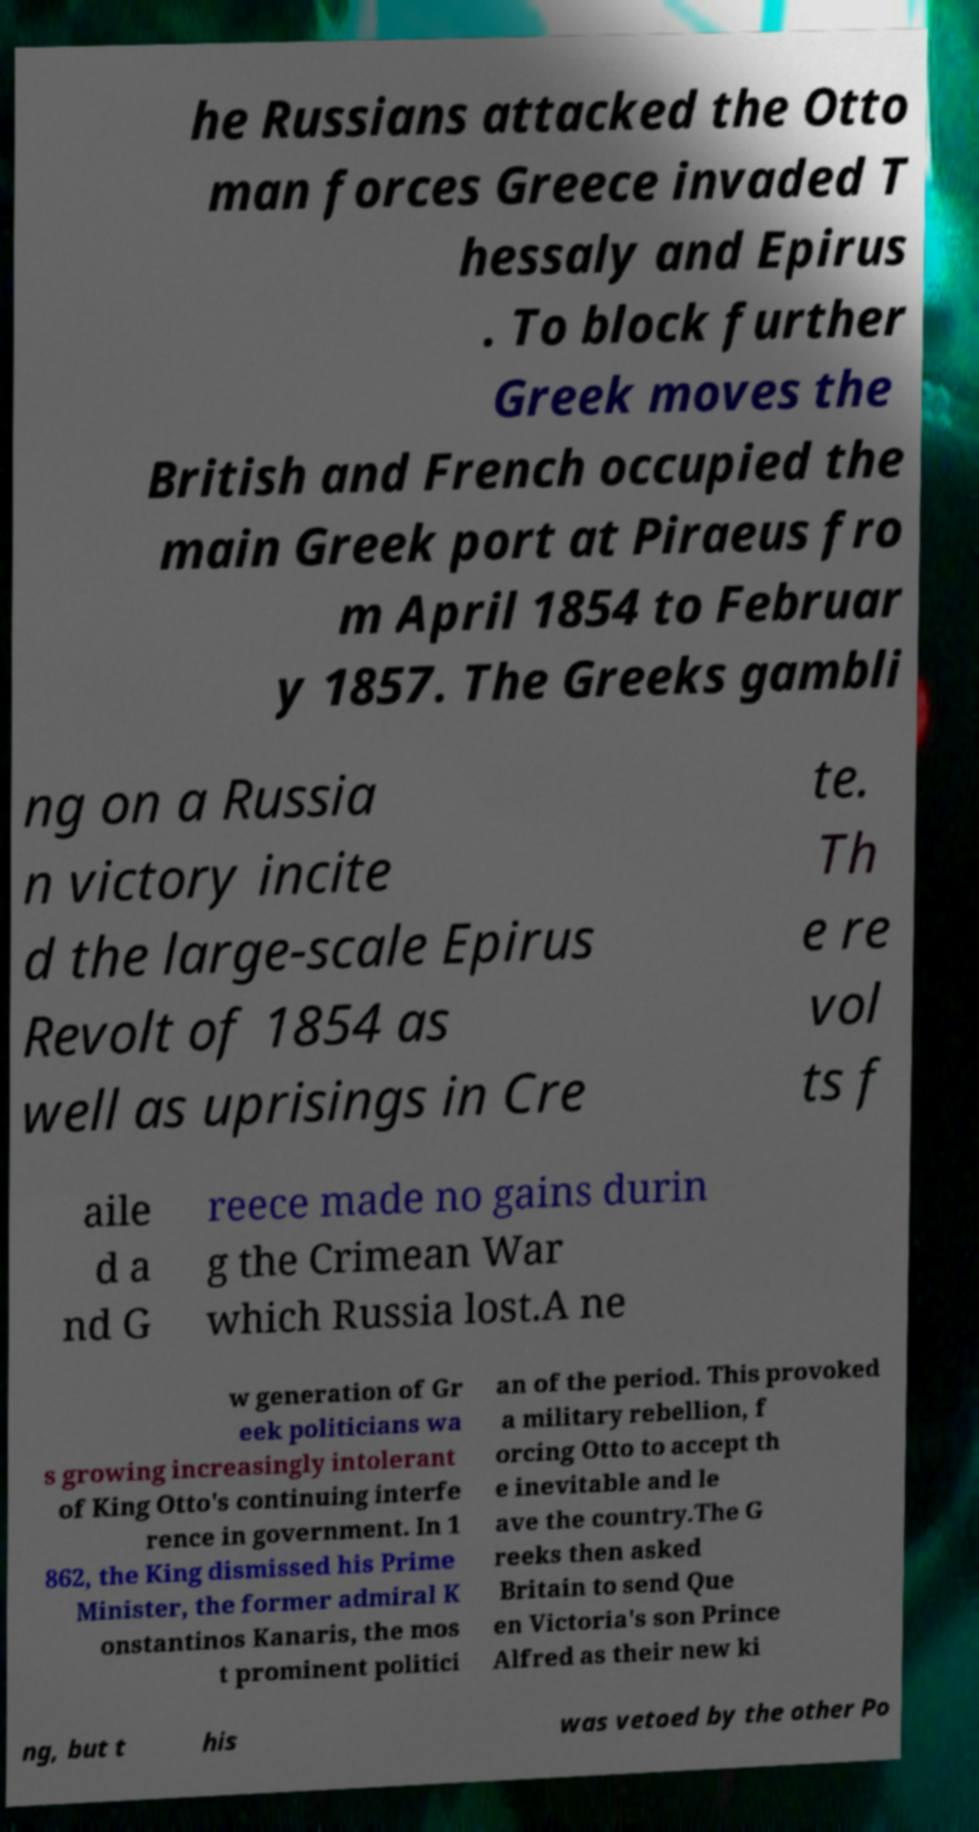Can you accurately transcribe the text from the provided image for me? he Russians attacked the Otto man forces Greece invaded T hessaly and Epirus . To block further Greek moves the British and French occupied the main Greek port at Piraeus fro m April 1854 to Februar y 1857. The Greeks gambli ng on a Russia n victory incite d the large-scale Epirus Revolt of 1854 as well as uprisings in Cre te. Th e re vol ts f aile d a nd G reece made no gains durin g the Crimean War which Russia lost.A ne w generation of Gr eek politicians wa s growing increasingly intolerant of King Otto's continuing interfe rence in government. In 1 862, the King dismissed his Prime Minister, the former admiral K onstantinos Kanaris, the mos t prominent politici an of the period. This provoked a military rebellion, f orcing Otto to accept th e inevitable and le ave the country.The G reeks then asked Britain to send Que en Victoria's son Prince Alfred as their new ki ng, but t his was vetoed by the other Po 